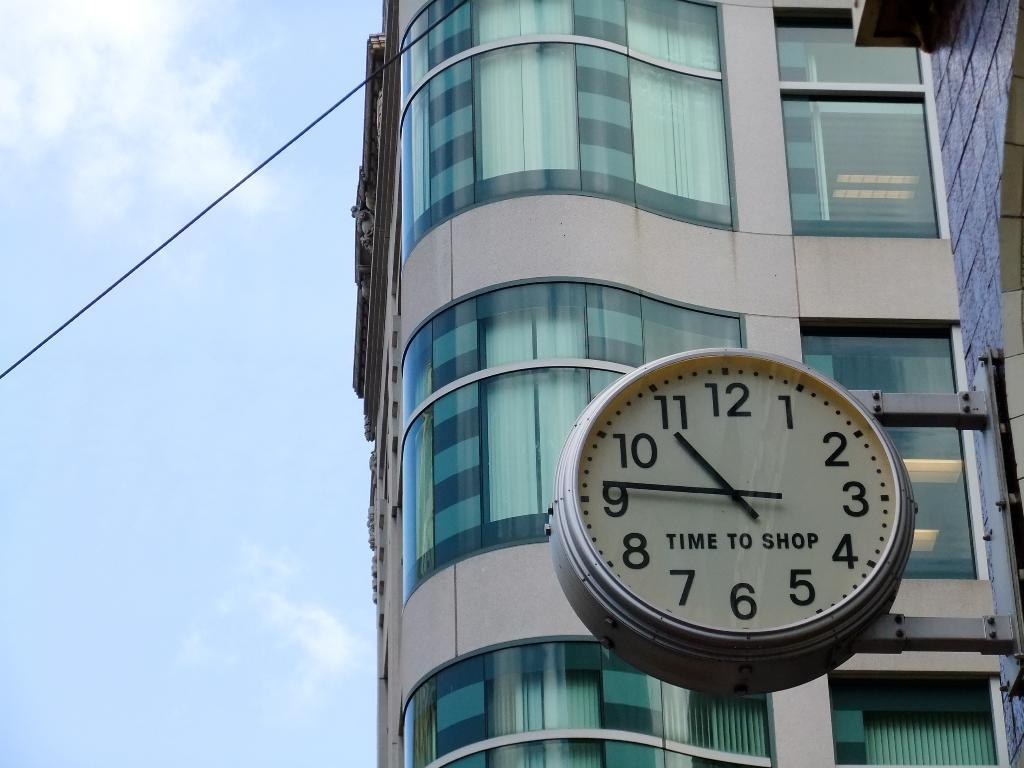What object can be seen on the wall in the image? There is a clock on the wall in the image. On which side of the image is the clock located? The clock is on the right side of the image. What can be seen in the background of the image? There is a building, windows, curtains, a wire, and clouds in the sky in the background of the image. What type of soup is being served in the cup in the image? There is no cup or soup present in the image. What channel is the television tuned to in the image? There is no television present in the image. 